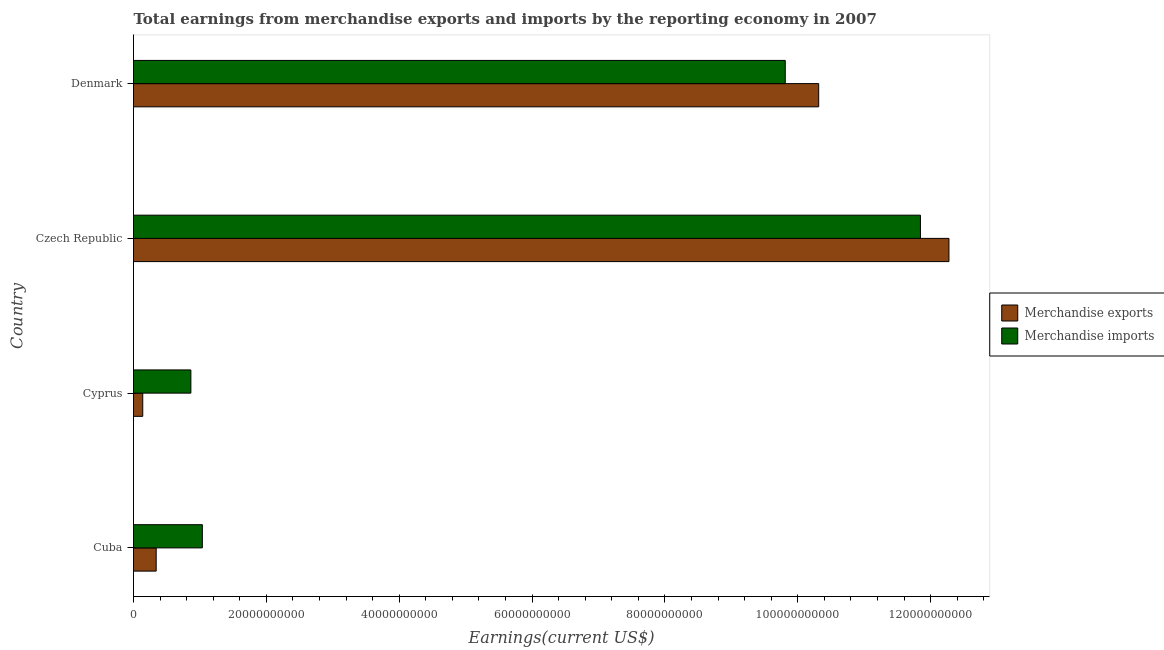How many different coloured bars are there?
Give a very brief answer. 2. Are the number of bars per tick equal to the number of legend labels?
Offer a very short reply. Yes. Are the number of bars on each tick of the Y-axis equal?
Keep it short and to the point. Yes. What is the label of the 4th group of bars from the top?
Your answer should be compact. Cuba. In how many cases, is the number of bars for a given country not equal to the number of legend labels?
Make the answer very short. 0. What is the earnings from merchandise imports in Denmark?
Make the answer very short. 9.81e+1. Across all countries, what is the maximum earnings from merchandise exports?
Give a very brief answer. 1.23e+11. Across all countries, what is the minimum earnings from merchandise imports?
Your response must be concise. 8.63e+09. In which country was the earnings from merchandise imports maximum?
Your response must be concise. Czech Republic. In which country was the earnings from merchandise exports minimum?
Your answer should be very brief. Cyprus. What is the total earnings from merchandise imports in the graph?
Provide a succinct answer. 2.36e+11. What is the difference between the earnings from merchandise imports in Cuba and that in Czech Republic?
Provide a short and direct response. -1.08e+11. What is the difference between the earnings from merchandise exports in Cyprus and the earnings from merchandise imports in Denmark?
Provide a short and direct response. -9.67e+1. What is the average earnings from merchandise imports per country?
Your answer should be compact. 5.89e+1. What is the difference between the earnings from merchandise exports and earnings from merchandise imports in Cyprus?
Your response must be concise. -7.24e+09. In how many countries, is the earnings from merchandise imports greater than 28000000000 US$?
Offer a very short reply. 2. What is the ratio of the earnings from merchandise imports in Cuba to that in Denmark?
Your answer should be very brief. 0.11. What is the difference between the highest and the second highest earnings from merchandise imports?
Make the answer very short. 2.04e+1. What is the difference between the highest and the lowest earnings from merchandise exports?
Your answer should be compact. 1.21e+11. What does the 2nd bar from the bottom in Cuba represents?
Provide a succinct answer. Merchandise imports. How many bars are there?
Provide a succinct answer. 8. Are all the bars in the graph horizontal?
Give a very brief answer. Yes. What is the difference between two consecutive major ticks on the X-axis?
Your response must be concise. 2.00e+1. Are the values on the major ticks of X-axis written in scientific E-notation?
Your answer should be very brief. No. Does the graph contain any zero values?
Keep it short and to the point. No. Does the graph contain grids?
Provide a succinct answer. No. Where does the legend appear in the graph?
Provide a short and direct response. Center right. How many legend labels are there?
Offer a terse response. 2. What is the title of the graph?
Offer a very short reply. Total earnings from merchandise exports and imports by the reporting economy in 2007. Does "ODA received" appear as one of the legend labels in the graph?
Ensure brevity in your answer.  No. What is the label or title of the X-axis?
Give a very brief answer. Earnings(current US$). What is the Earnings(current US$) of Merchandise exports in Cuba?
Offer a terse response. 3.41e+09. What is the Earnings(current US$) of Merchandise imports in Cuba?
Offer a very short reply. 1.04e+1. What is the Earnings(current US$) in Merchandise exports in Cyprus?
Your answer should be very brief. 1.39e+09. What is the Earnings(current US$) of Merchandise imports in Cyprus?
Keep it short and to the point. 8.63e+09. What is the Earnings(current US$) in Merchandise exports in Czech Republic?
Give a very brief answer. 1.23e+11. What is the Earnings(current US$) of Merchandise imports in Czech Republic?
Your answer should be compact. 1.18e+11. What is the Earnings(current US$) of Merchandise exports in Denmark?
Keep it short and to the point. 1.03e+11. What is the Earnings(current US$) in Merchandise imports in Denmark?
Your response must be concise. 9.81e+1. Across all countries, what is the maximum Earnings(current US$) in Merchandise exports?
Provide a succinct answer. 1.23e+11. Across all countries, what is the maximum Earnings(current US$) in Merchandise imports?
Keep it short and to the point. 1.18e+11. Across all countries, what is the minimum Earnings(current US$) of Merchandise exports?
Provide a succinct answer. 1.39e+09. Across all countries, what is the minimum Earnings(current US$) in Merchandise imports?
Provide a succinct answer. 8.63e+09. What is the total Earnings(current US$) in Merchandise exports in the graph?
Offer a very short reply. 2.31e+11. What is the total Earnings(current US$) of Merchandise imports in the graph?
Make the answer very short. 2.36e+11. What is the difference between the Earnings(current US$) in Merchandise exports in Cuba and that in Cyprus?
Offer a terse response. 2.02e+09. What is the difference between the Earnings(current US$) of Merchandise imports in Cuba and that in Cyprus?
Offer a terse response. 1.73e+09. What is the difference between the Earnings(current US$) in Merchandise exports in Cuba and that in Czech Republic?
Your response must be concise. -1.19e+11. What is the difference between the Earnings(current US$) in Merchandise imports in Cuba and that in Czech Republic?
Keep it short and to the point. -1.08e+11. What is the difference between the Earnings(current US$) in Merchandise exports in Cuba and that in Denmark?
Make the answer very short. -9.97e+1. What is the difference between the Earnings(current US$) in Merchandise imports in Cuba and that in Denmark?
Make the answer very short. -8.77e+1. What is the difference between the Earnings(current US$) in Merchandise exports in Cyprus and that in Czech Republic?
Your response must be concise. -1.21e+11. What is the difference between the Earnings(current US$) in Merchandise imports in Cyprus and that in Czech Republic?
Provide a succinct answer. -1.10e+11. What is the difference between the Earnings(current US$) of Merchandise exports in Cyprus and that in Denmark?
Offer a very short reply. -1.02e+11. What is the difference between the Earnings(current US$) of Merchandise imports in Cyprus and that in Denmark?
Your response must be concise. -8.95e+1. What is the difference between the Earnings(current US$) in Merchandise exports in Czech Republic and that in Denmark?
Keep it short and to the point. 1.96e+1. What is the difference between the Earnings(current US$) in Merchandise imports in Czech Republic and that in Denmark?
Provide a succinct answer. 2.04e+1. What is the difference between the Earnings(current US$) in Merchandise exports in Cuba and the Earnings(current US$) in Merchandise imports in Cyprus?
Keep it short and to the point. -5.22e+09. What is the difference between the Earnings(current US$) in Merchandise exports in Cuba and the Earnings(current US$) in Merchandise imports in Czech Republic?
Provide a short and direct response. -1.15e+11. What is the difference between the Earnings(current US$) in Merchandise exports in Cuba and the Earnings(current US$) in Merchandise imports in Denmark?
Provide a succinct answer. -9.47e+1. What is the difference between the Earnings(current US$) in Merchandise exports in Cyprus and the Earnings(current US$) in Merchandise imports in Czech Republic?
Keep it short and to the point. -1.17e+11. What is the difference between the Earnings(current US$) of Merchandise exports in Cyprus and the Earnings(current US$) of Merchandise imports in Denmark?
Your answer should be compact. -9.67e+1. What is the difference between the Earnings(current US$) of Merchandise exports in Czech Republic and the Earnings(current US$) of Merchandise imports in Denmark?
Give a very brief answer. 2.46e+1. What is the average Earnings(current US$) in Merchandise exports per country?
Provide a succinct answer. 5.77e+1. What is the average Earnings(current US$) of Merchandise imports per country?
Offer a terse response. 5.89e+1. What is the difference between the Earnings(current US$) in Merchandise exports and Earnings(current US$) in Merchandise imports in Cuba?
Make the answer very short. -6.95e+09. What is the difference between the Earnings(current US$) of Merchandise exports and Earnings(current US$) of Merchandise imports in Cyprus?
Keep it short and to the point. -7.24e+09. What is the difference between the Earnings(current US$) of Merchandise exports and Earnings(current US$) of Merchandise imports in Czech Republic?
Keep it short and to the point. 4.29e+09. What is the difference between the Earnings(current US$) of Merchandise exports and Earnings(current US$) of Merchandise imports in Denmark?
Your answer should be very brief. 5.03e+09. What is the ratio of the Earnings(current US$) of Merchandise exports in Cuba to that in Cyprus?
Provide a short and direct response. 2.45. What is the ratio of the Earnings(current US$) of Merchandise imports in Cuba to that in Cyprus?
Offer a terse response. 1.2. What is the ratio of the Earnings(current US$) in Merchandise exports in Cuba to that in Czech Republic?
Keep it short and to the point. 0.03. What is the ratio of the Earnings(current US$) of Merchandise imports in Cuba to that in Czech Republic?
Your answer should be very brief. 0.09. What is the ratio of the Earnings(current US$) of Merchandise exports in Cuba to that in Denmark?
Offer a very short reply. 0.03. What is the ratio of the Earnings(current US$) in Merchandise imports in Cuba to that in Denmark?
Your answer should be very brief. 0.11. What is the ratio of the Earnings(current US$) in Merchandise exports in Cyprus to that in Czech Republic?
Make the answer very short. 0.01. What is the ratio of the Earnings(current US$) of Merchandise imports in Cyprus to that in Czech Republic?
Ensure brevity in your answer.  0.07. What is the ratio of the Earnings(current US$) in Merchandise exports in Cyprus to that in Denmark?
Your answer should be very brief. 0.01. What is the ratio of the Earnings(current US$) of Merchandise imports in Cyprus to that in Denmark?
Offer a very short reply. 0.09. What is the ratio of the Earnings(current US$) of Merchandise exports in Czech Republic to that in Denmark?
Offer a terse response. 1.19. What is the ratio of the Earnings(current US$) of Merchandise imports in Czech Republic to that in Denmark?
Ensure brevity in your answer.  1.21. What is the difference between the highest and the second highest Earnings(current US$) in Merchandise exports?
Make the answer very short. 1.96e+1. What is the difference between the highest and the second highest Earnings(current US$) of Merchandise imports?
Offer a terse response. 2.04e+1. What is the difference between the highest and the lowest Earnings(current US$) of Merchandise exports?
Your answer should be very brief. 1.21e+11. What is the difference between the highest and the lowest Earnings(current US$) in Merchandise imports?
Offer a very short reply. 1.10e+11. 